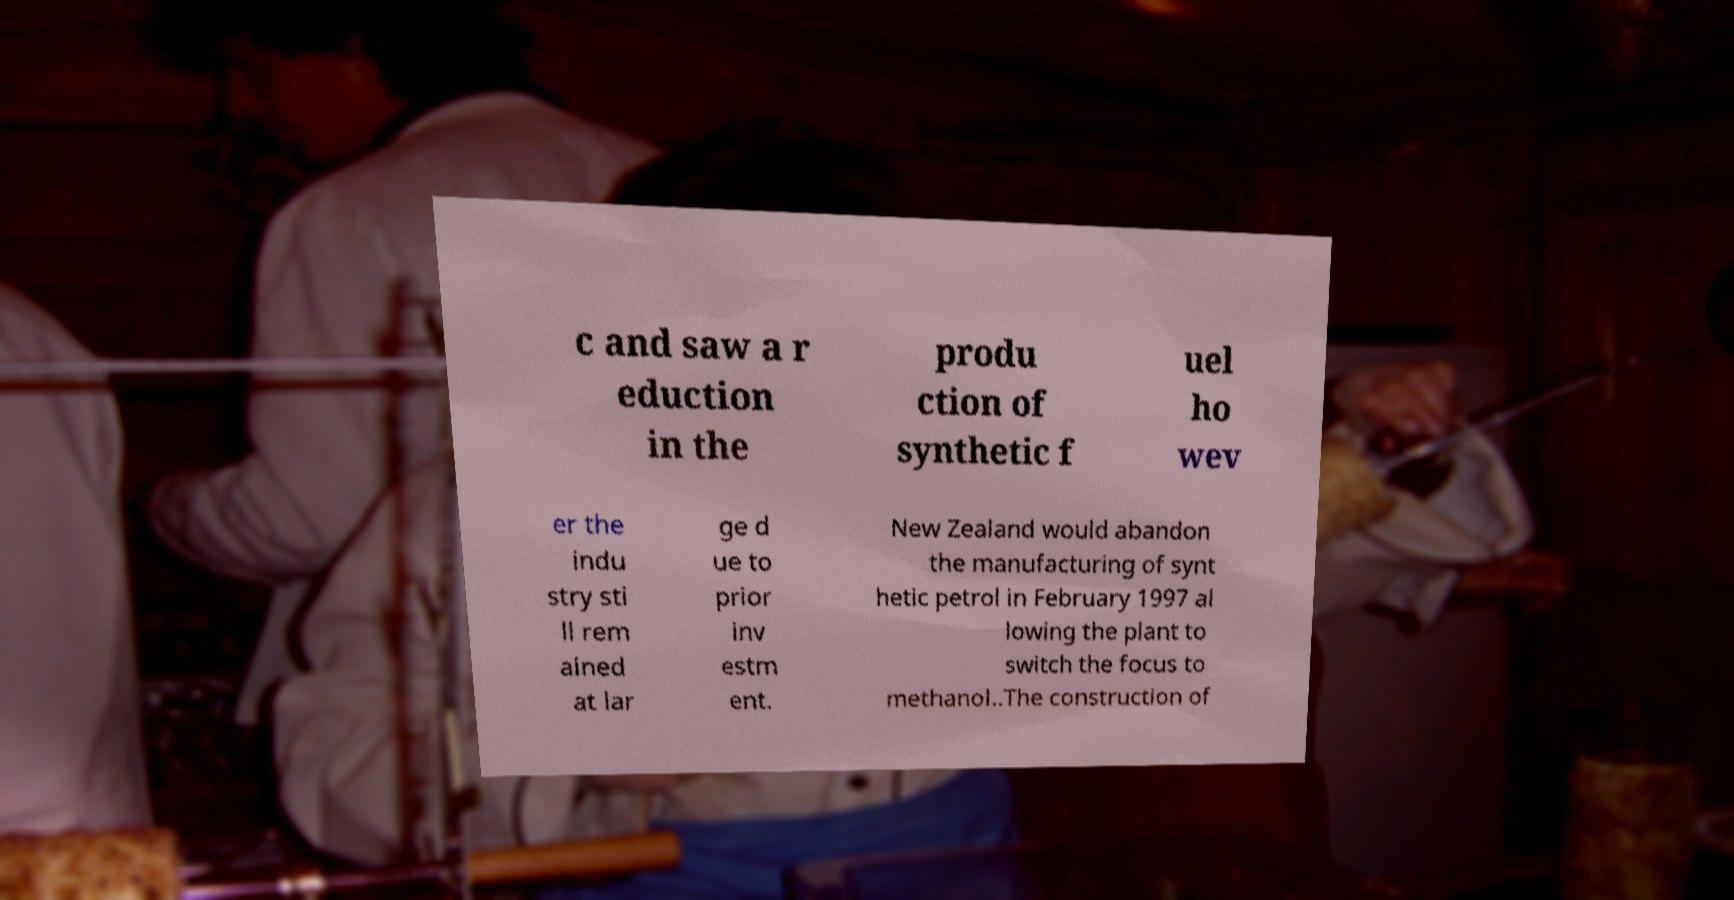For documentation purposes, I need the text within this image transcribed. Could you provide that? c and saw a r eduction in the produ ction of synthetic f uel ho wev er the indu stry sti ll rem ained at lar ge d ue to prior inv estm ent. New Zealand would abandon the manufacturing of synt hetic petrol in February 1997 al lowing the plant to switch the focus to methanol..The construction of 